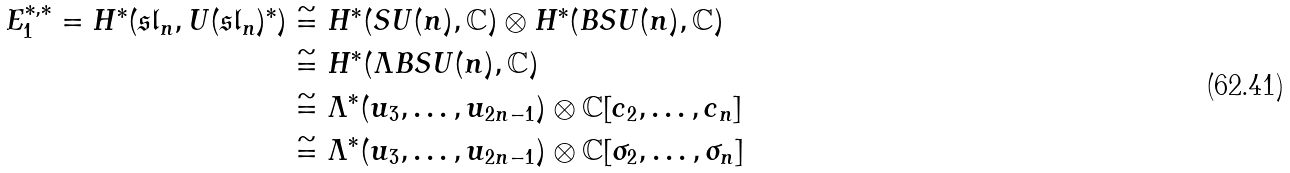Convert formula to latex. <formula><loc_0><loc_0><loc_500><loc_500>E _ { 1 } ^ { * , * } = H ^ { * } ( \mathfrak { s l } _ { n } , U ( \mathfrak { s l } _ { n } ) ^ { * } ) & \cong H ^ { * } ( S U ( n ) , \mathbb { C } ) \otimes H ^ { * } ( B S U ( n ) , \mathbb { C } ) \\ & \cong H ^ { * } ( \Lambda B S U ( n ) , \mathbb { C } ) \\ & \cong \Lambda ^ { * } ( u _ { 3 } , \dots , u _ { 2 n - 1 } ) \otimes \mathbb { C } [ c _ { 2 } , \dots , c _ { n } ] \\ & \cong \Lambda ^ { * } ( u _ { 3 } , \dots , u _ { 2 n - 1 } ) \otimes \mathbb { C } [ \sigma _ { 2 } , \dots , \sigma _ { n } ]</formula> 